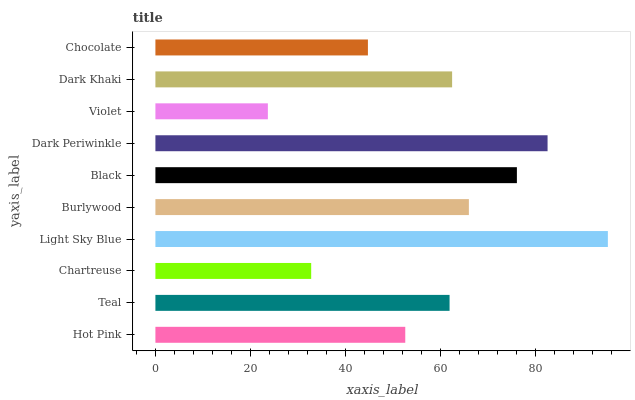Is Violet the minimum?
Answer yes or no. Yes. Is Light Sky Blue the maximum?
Answer yes or no. Yes. Is Teal the minimum?
Answer yes or no. No. Is Teal the maximum?
Answer yes or no. No. Is Teal greater than Hot Pink?
Answer yes or no. Yes. Is Hot Pink less than Teal?
Answer yes or no. Yes. Is Hot Pink greater than Teal?
Answer yes or no. No. Is Teal less than Hot Pink?
Answer yes or no. No. Is Dark Khaki the high median?
Answer yes or no. Yes. Is Teal the low median?
Answer yes or no. Yes. Is Black the high median?
Answer yes or no. No. Is Violet the low median?
Answer yes or no. No. 